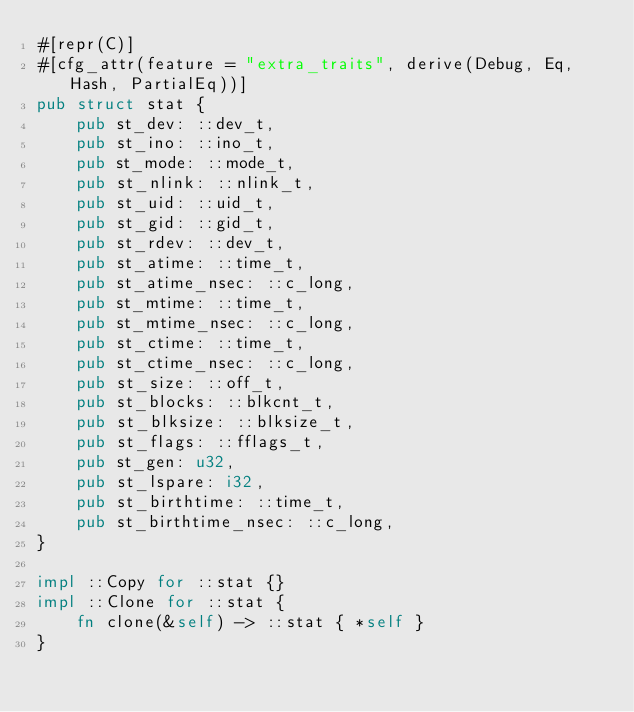Convert code to text. <code><loc_0><loc_0><loc_500><loc_500><_Rust_>#[repr(C)]
#[cfg_attr(feature = "extra_traits", derive(Debug, Eq, Hash, PartialEq))]
pub struct stat {
    pub st_dev: ::dev_t,
    pub st_ino: ::ino_t,
    pub st_mode: ::mode_t,
    pub st_nlink: ::nlink_t,
    pub st_uid: ::uid_t,
    pub st_gid: ::gid_t,
    pub st_rdev: ::dev_t,
    pub st_atime: ::time_t,
    pub st_atime_nsec: ::c_long,
    pub st_mtime: ::time_t,
    pub st_mtime_nsec: ::c_long,
    pub st_ctime: ::time_t,
    pub st_ctime_nsec: ::c_long,
    pub st_size: ::off_t,
    pub st_blocks: ::blkcnt_t,
    pub st_blksize: ::blksize_t,
    pub st_flags: ::fflags_t,
    pub st_gen: u32,
    pub st_lspare: i32,
    pub st_birthtime: ::time_t,
    pub st_birthtime_nsec: ::c_long,
}

impl ::Copy for ::stat {}
impl ::Clone for ::stat {
    fn clone(&self) -> ::stat { *self }
}
</code> 